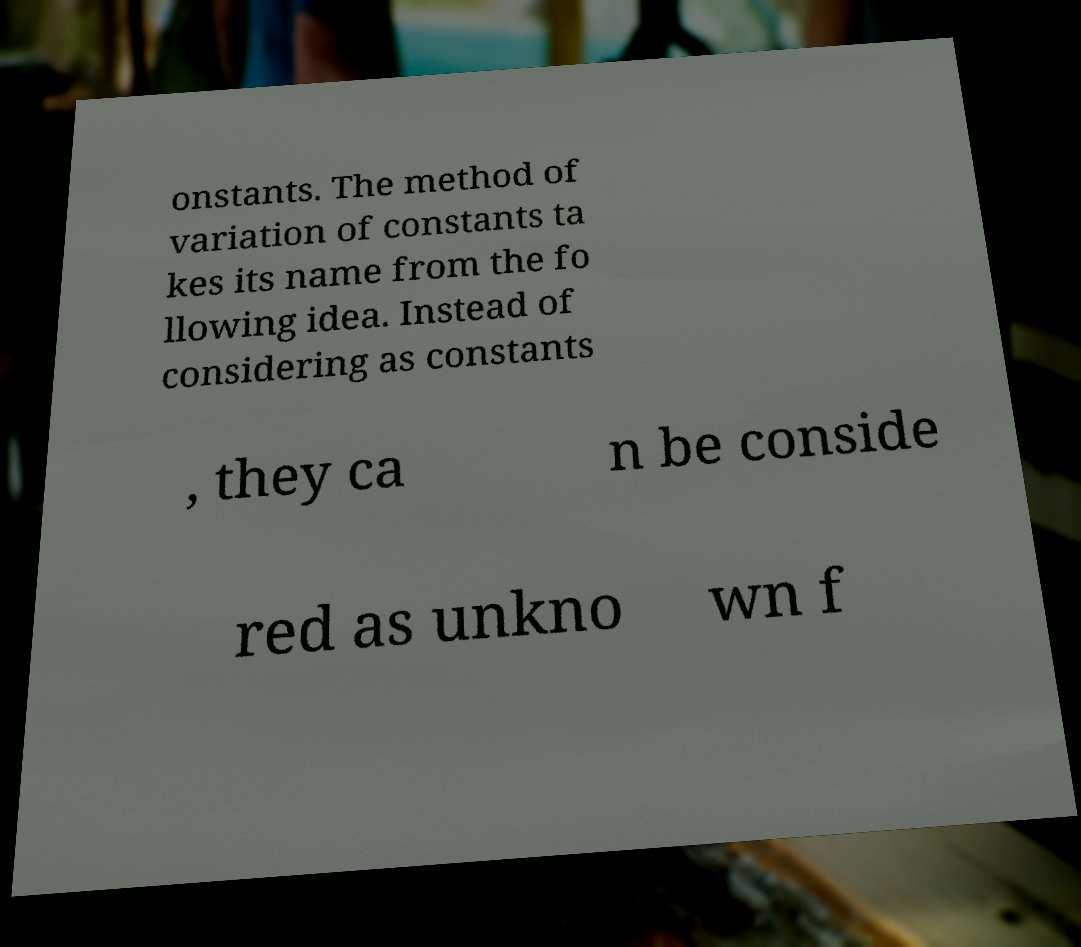I need the written content from this picture converted into text. Can you do that? onstants. The method of variation of constants ta kes its name from the fo llowing idea. Instead of considering as constants , they ca n be conside red as unkno wn f 